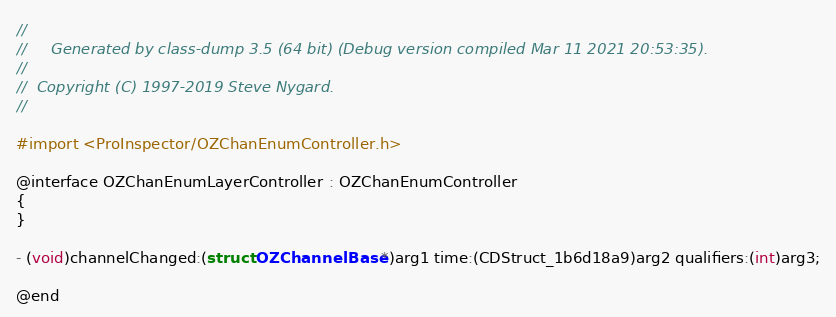Convert code to text. <code><loc_0><loc_0><loc_500><loc_500><_C_>//
//     Generated by class-dump 3.5 (64 bit) (Debug version compiled Mar 11 2021 20:53:35).
//
//  Copyright (C) 1997-2019 Steve Nygard.
//

#import <ProInspector/OZChanEnumController.h>

@interface OZChanEnumLayerController : OZChanEnumController
{
}

- (void)channelChanged:(struct OZChannelBase *)arg1 time:(CDStruct_1b6d18a9)arg2 qualifiers:(int)arg3;

@end

</code> 